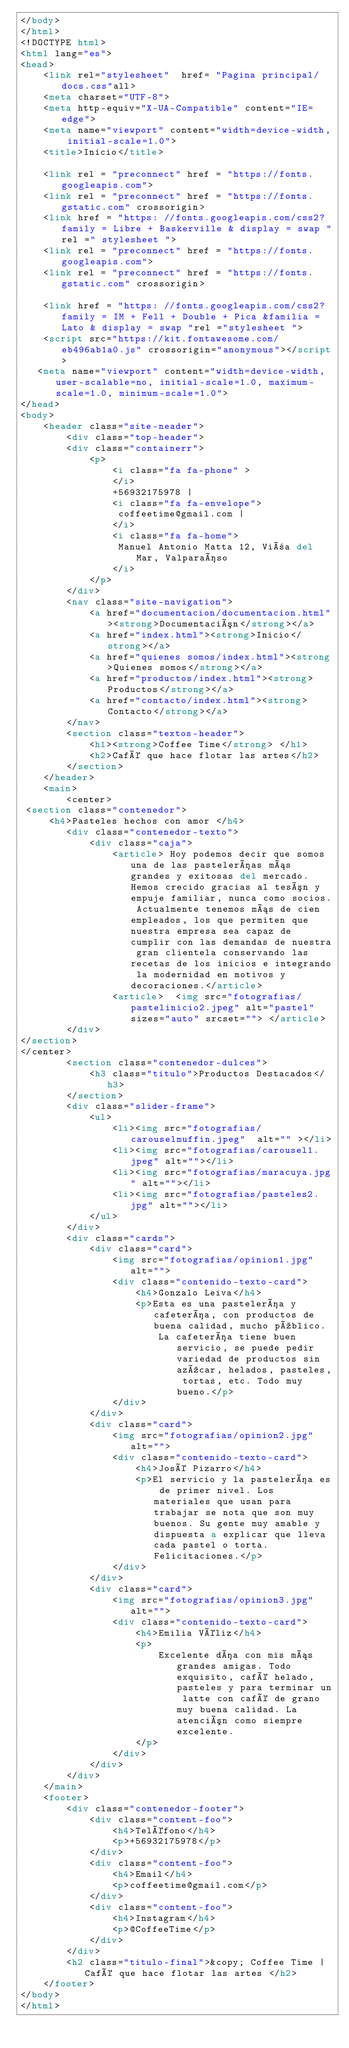<code> <loc_0><loc_0><loc_500><loc_500><_HTML_></body>
</html>
<!DOCTYPE html>
<html lang="es">
<head>
    <link rel="stylesheet"  href= "Pagina principal/docs.css"all>
    <meta charset="UTF-8">
    <meta http-equiv="X-UA-Compatible" content="IE=edge">
    <meta name="viewport" content="width=device-width, initial-scale=1.0">
    <title>Inicio</title>
  
    <link rel = "preconnect" href = "https://fonts.googleapis.com">
    <link rel = "preconnect" href = "https://fonts.gstatic.com" crossorigin>
    <link href = "https: //fonts.googleapis.com/css2? family = Libre + Baskerville & display = swap "rel =" stylesheet ">
    <link rel = "preconnect" href = "https://fonts.googleapis.com">
    <link rel = "preconnect" href = "https://fonts.gstatic.com" crossorigin>
 
    <link href = "https: //fonts.googleapis.com/css2? family = IM + Fell + Double + Pica &familia = Lato & display = swap "rel ="stylesheet ">
    <script src="https://kit.fontawesome.com/eb496ab1a0.js" crossorigin="anonymous"></script>
   <meta name="viewport" content="width=device-width, user-scalable=no, initial-scale=1.0, maximum-scale=1.0, minimum-scale=1.0">
</head>
<body>
    <header class="site-neader">
        <div class="top-header">
        <div class="containerr">
            <p>
                <i class="fa fa-phone" > 
                </i>
                +56932175978 | 
                <i class="fa fa-envelope"> 
                 coffeetime@gmail.com |
                </i>
                <i class="fa fa-home">
                 Manuel Antonio Matta 12, Viña del Mar, Valparaíso
                </i>
            </p>
        </div>
        <nav class="site-navigation">
            <a href="documentacion/documentacion.html"><strong>Documentación</strong></a>
            <a href="index.html"><strong>Inicio</strong></a>
            <a href="quienes somos/index.html"><strong>Quienes somos</strong></a>
            <a href="productos/index.html"><strong>Productos</strong></a>
            <a href="contacto/index.html"><strong>Contacto</strong></a>
        </nav>
		<section class="textos-header">
            <h1><strong>Coffee Time</strong> </h1>
            <h2>Café que hace flotar las artes</h2>
        </section>
    </header>
    <main>
        <center>
 <section class="contenedor">
     <h4>Pasteles hechos con amor </h4>
        <div class="contenedor-texto">
            <div class="caja">
                <article> Hoy podemos decir que somos una de las pastelerías más grandes y exitosas del mercado. Hemos crecido gracias al tesón y empuje familiar, nunca como socios. Actualmente tenemos más de cien empleados, los que permiten que nuestra empresa sea capaz de cumplir con las demandas de nuestra gran clientela conservando las recetas de los inicios e integrando la modernidad en motivos y decoraciones.</article>
                <article>  <img src="fotografias/pastelinicio2.jpeg" alt="pastel" sizes="auto" srcset=""> </article>
        </div>
</section>
</center>
        <section class="contenedor-dulces">
            <h3 class="titulo">Productos Destacados</h3>
        </section>
        <div class="slider-frame">
            <ul>
                <li><img src="fotografias/carouselmuffin.jpeg"  alt="" ></li>
                <li><img src="fotografias/carousel1.jpeg" alt=""></li>
                <li><img src="fotografias/maracuya.jpg" alt=""></li>
                <li><img src="fotografias/pasteles2.jpg" alt=""></li>
            </ul>
        </div>  
        <div class="cards">
            <div class="card">
                <img src="fotografias/opinion1.jpg" alt="">
                <div class="contenido-texto-card">
                    <h4>Gonzalo Leiva</h4>
                    <p>Esta es una pastelería y cafetería, con productos de buena calidad, mucho público.
                        La cafetería tiene buen servicio, se puede pedir variedad de productos sin azúcar, helados, pasteles, tortas, etc. Todo muy bueno.</p>
                </div>
            </div>
            <div class="card">
                <img src="fotografias/opinion2.jpg" alt="">
                <div class="contenido-texto-card">
                    <h4>José Pizarro</h4> 
                    <p>El servicio y la pastelería es de primer nivel. Los materiales que usan para trabajar se nota que son muy buenos. Su gente muy amable y dispuesta a explicar que lleva cada pastel o torta. Felicitaciones.</p>
                </div>
            </div>
            <div class="card">
                <img src="fotografias/opinion3.jpg" alt="">
                <div class="contenido-texto-card">
                    <h4>Emilia Véliz</h4>
                    <p> 
                        Excelente día con mis más grandes amigas. Todo exquisito, café helado, pasteles y para terminar un latte con café de grano muy buena calidad. La atención como siempre excelente.
                    </p>
                </div>
            </div>    
        </div>
    </main>
    <footer>
        <div class="contenedor-footer">
            <div class="content-foo">
                <h4>Teléfono</h4>
                <p>+56932175978</p> 
            </div>
            <div class="content-foo">
                <h4>Email</h4>
                <p>coffeetime@gmail.com</p> 
            </div>
            <div class="content-foo">
                <h4>Instagram</h4>
                <p>@CoffeeTime</p> 
            </div>
        </div>
        <h2 class="titulo-final">&copy; Coffee Time | Café que hace flotar las artes </h2>
    </footer>
</body>
</html>


</code> 